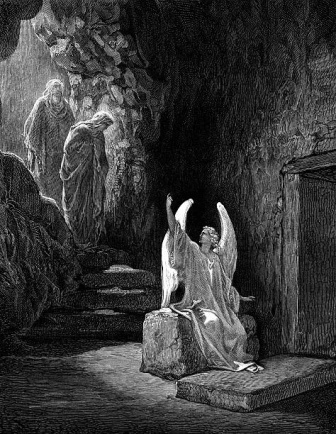Analyze the image in a comprehensive and detailed manner. The image is a highly detailed black and white illustration set inside a dimly lit cave. At the center, an angelic figure kneels on a rock, with its wings majestically spread wide. This angel is adorned in a flowing robe, and a halo encircles its head, symbolizing its celestial nature. 

In the background, there are two more figures ascending a stone staircase that winds upward through the cave. Both figures have draped garments and their heads are covered, which lends an air of mystery to their identities. The staircase itself is rugged and uneven, emphasizing the natural cave setting. 

On the right side of the illustration, there is a sturdy wooden door set into the rock wall. This door suggests a potential passage to another part of the cave or to the outside world. The texture and shading used in the image create a remarkable sense of depth and realism, drawing attention to the intricate details of the scene. Despite the monochrome palette, the use of light and shadow effectively conveys the spatial dimensions and mood of the image, making it a compelling and evocative piece. 